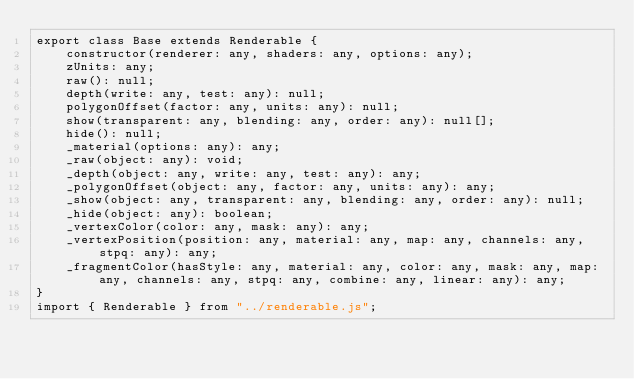<code> <loc_0><loc_0><loc_500><loc_500><_TypeScript_>export class Base extends Renderable {
    constructor(renderer: any, shaders: any, options: any);
    zUnits: any;
    raw(): null;
    depth(write: any, test: any): null;
    polygonOffset(factor: any, units: any): null;
    show(transparent: any, blending: any, order: any): null[];
    hide(): null;
    _material(options: any): any;
    _raw(object: any): void;
    _depth(object: any, write: any, test: any): any;
    _polygonOffset(object: any, factor: any, units: any): any;
    _show(object: any, transparent: any, blending: any, order: any): null;
    _hide(object: any): boolean;
    _vertexColor(color: any, mask: any): any;
    _vertexPosition(position: any, material: any, map: any, channels: any, stpq: any): any;
    _fragmentColor(hasStyle: any, material: any, color: any, mask: any, map: any, channels: any, stpq: any, combine: any, linear: any): any;
}
import { Renderable } from "../renderable.js";
</code> 